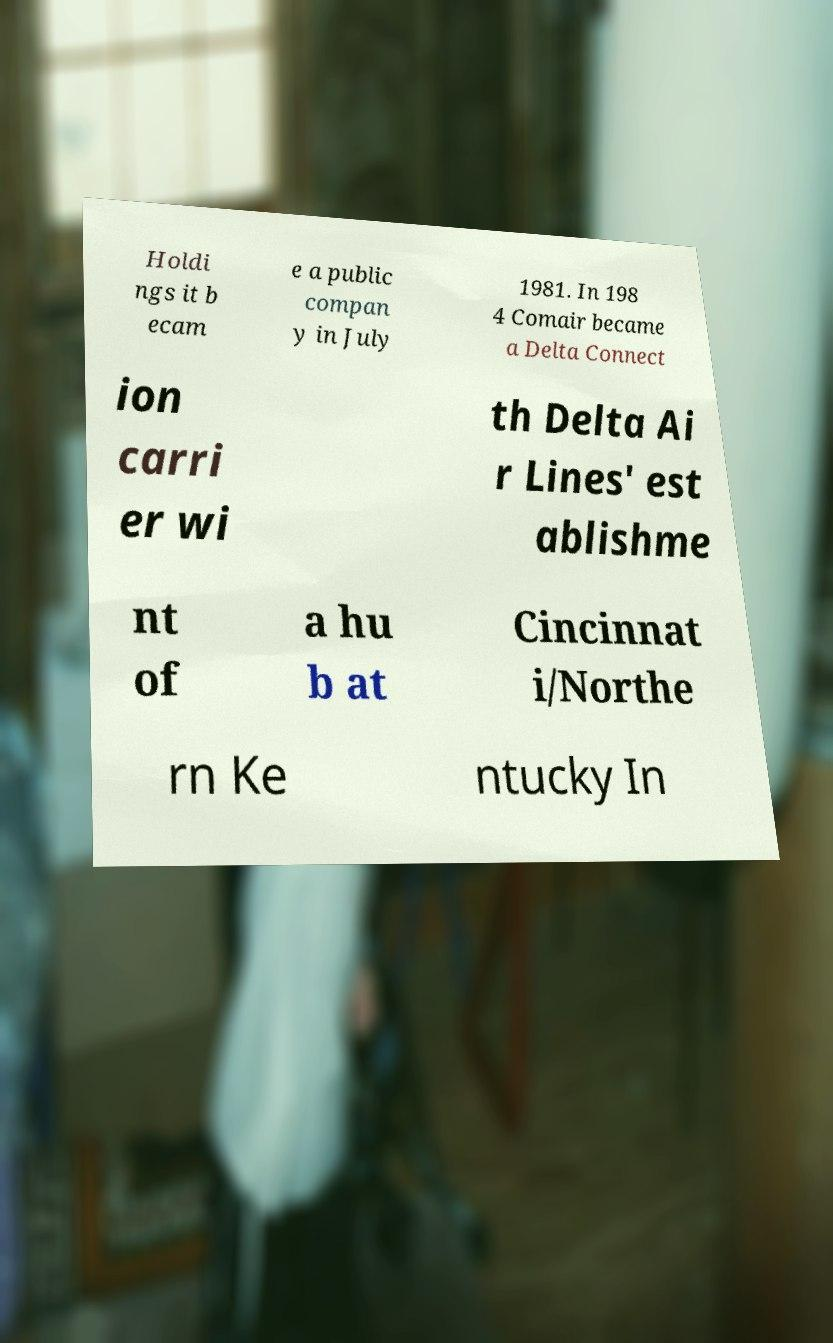Please read and relay the text visible in this image. What does it say? Holdi ngs it b ecam e a public compan y in July 1981. In 198 4 Comair became a Delta Connect ion carri er wi th Delta Ai r Lines' est ablishme nt of a hu b at Cincinnat i/Northe rn Ke ntucky In 